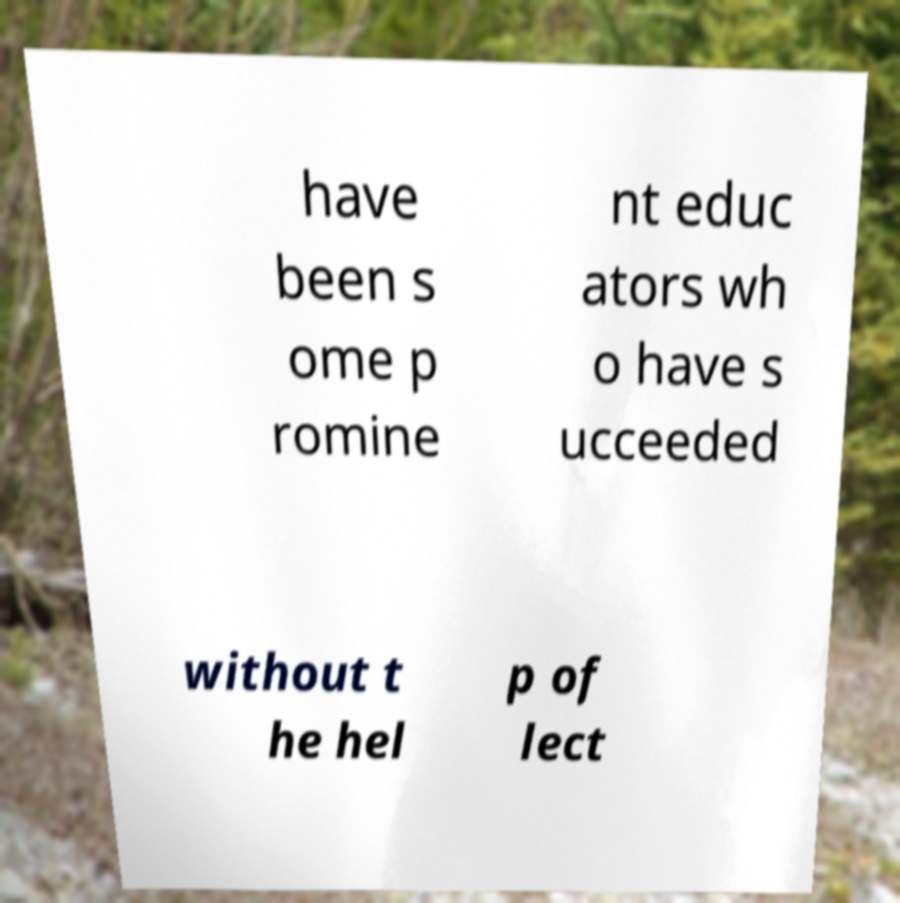There's text embedded in this image that I need extracted. Can you transcribe it verbatim? have been s ome p romine nt educ ators wh o have s ucceeded without t he hel p of lect 